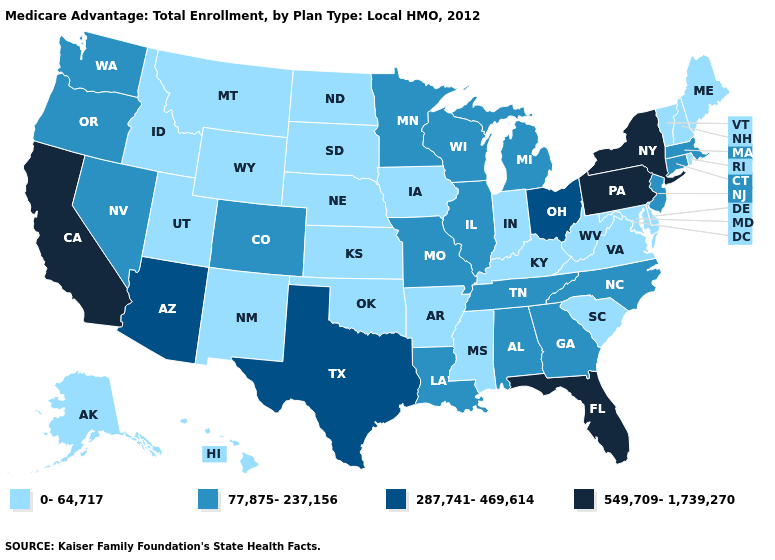What is the lowest value in states that border Nevada?
Short answer required. 0-64,717. Which states have the lowest value in the Northeast?
Quick response, please. Maine, New Hampshire, Rhode Island, Vermont. Name the states that have a value in the range 549,709-1,739,270?
Answer briefly. California, Florida, New York, Pennsylvania. Among the states that border Montana , which have the lowest value?
Write a very short answer. Idaho, North Dakota, South Dakota, Wyoming. What is the highest value in the USA?
Keep it brief. 549,709-1,739,270. Name the states that have a value in the range 0-64,717?
Keep it brief. Alaska, Arkansas, Delaware, Hawaii, Iowa, Idaho, Indiana, Kansas, Kentucky, Maryland, Maine, Mississippi, Montana, North Dakota, Nebraska, New Hampshire, New Mexico, Oklahoma, Rhode Island, South Carolina, South Dakota, Utah, Virginia, Vermont, West Virginia, Wyoming. Does the map have missing data?
Keep it brief. No. Among the states that border New Hampshire , which have the highest value?
Write a very short answer. Massachusetts. Name the states that have a value in the range 549,709-1,739,270?
Answer briefly. California, Florida, New York, Pennsylvania. What is the value of West Virginia?
Be succinct. 0-64,717. Name the states that have a value in the range 0-64,717?
Give a very brief answer. Alaska, Arkansas, Delaware, Hawaii, Iowa, Idaho, Indiana, Kansas, Kentucky, Maryland, Maine, Mississippi, Montana, North Dakota, Nebraska, New Hampshire, New Mexico, Oklahoma, Rhode Island, South Carolina, South Dakota, Utah, Virginia, Vermont, West Virginia, Wyoming. Which states have the lowest value in the USA?
Keep it brief. Alaska, Arkansas, Delaware, Hawaii, Iowa, Idaho, Indiana, Kansas, Kentucky, Maryland, Maine, Mississippi, Montana, North Dakota, Nebraska, New Hampshire, New Mexico, Oklahoma, Rhode Island, South Carolina, South Dakota, Utah, Virginia, Vermont, West Virginia, Wyoming. What is the value of Oklahoma?
Give a very brief answer. 0-64,717. How many symbols are there in the legend?
Be succinct. 4. Name the states that have a value in the range 77,875-237,156?
Concise answer only. Alabama, Colorado, Connecticut, Georgia, Illinois, Louisiana, Massachusetts, Michigan, Minnesota, Missouri, North Carolina, New Jersey, Nevada, Oregon, Tennessee, Washington, Wisconsin. 